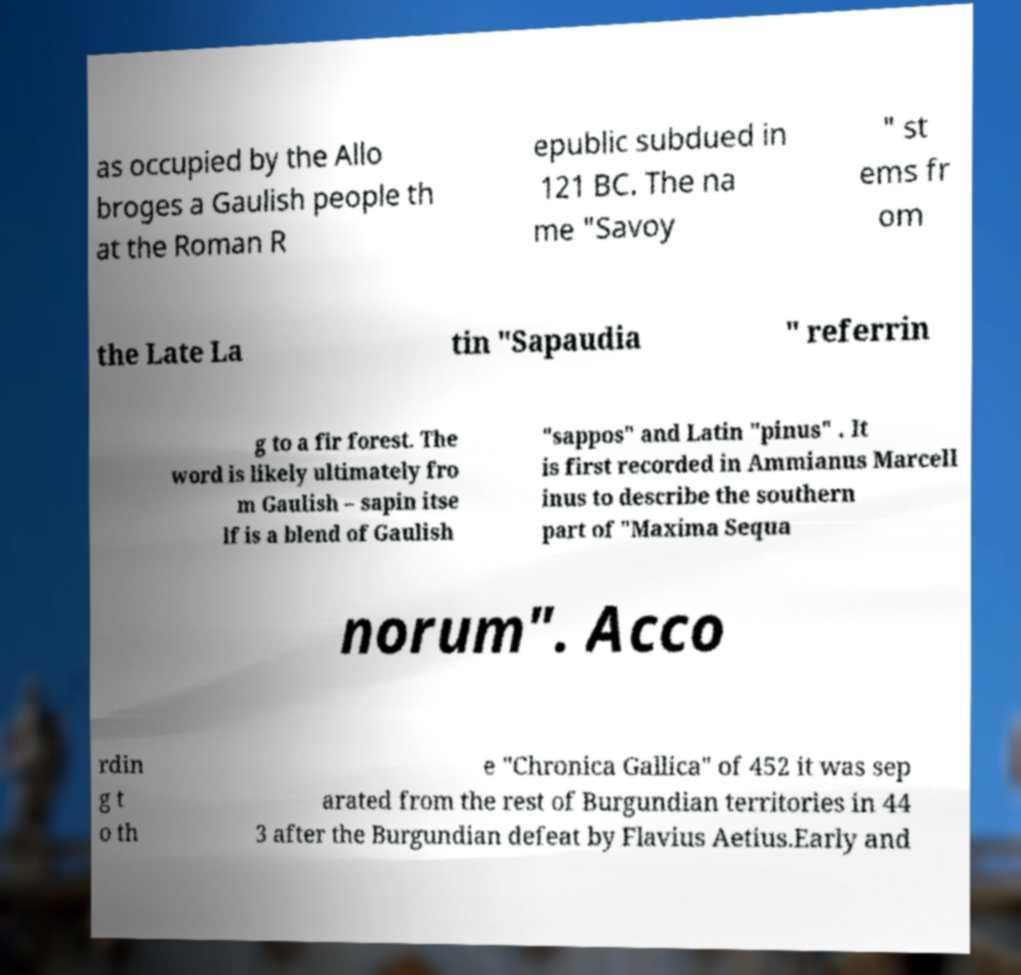Could you extract and type out the text from this image? as occupied by the Allo broges a Gaulish people th at the Roman R epublic subdued in 121 BC. The na me "Savoy " st ems fr om the Late La tin "Sapaudia " referrin g to a fir forest. The word is likely ultimately fro m Gaulish – sapin itse lf is a blend of Gaulish "sappos" and Latin "pinus" . It is first recorded in Ammianus Marcell inus to describe the southern part of "Maxima Sequa norum". Acco rdin g t o th e "Chronica Gallica" of 452 it was sep arated from the rest of Burgundian territories in 44 3 after the Burgundian defeat by Flavius Aetius.Early and 